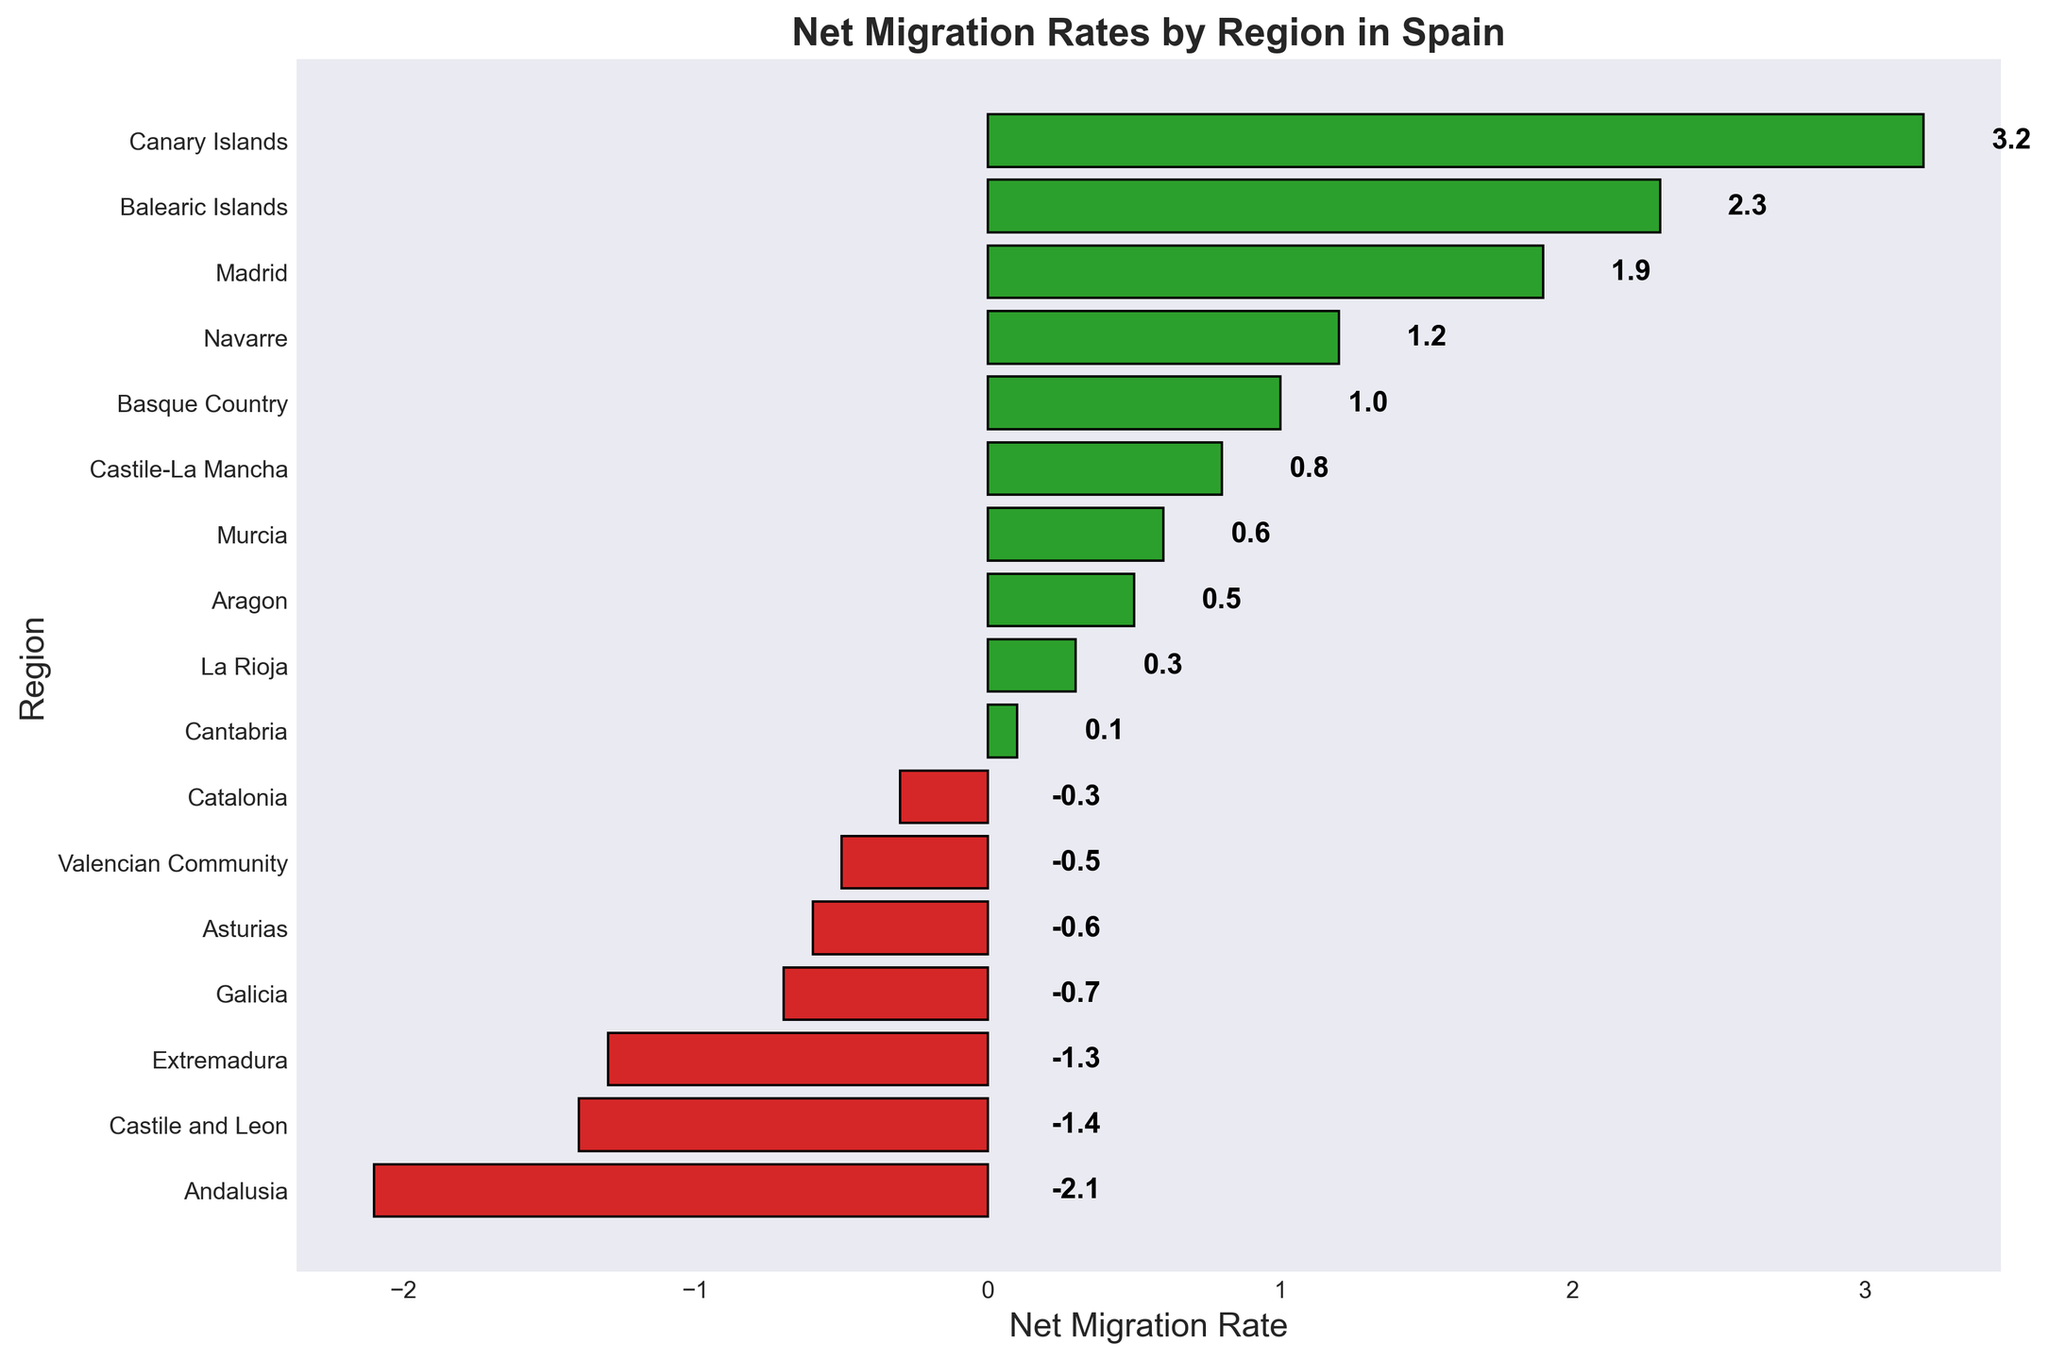What region has the highest net migration rate? The highest net migration rate is represented by the tallest green bar. The tallest green bar belongs to the Canary Islands.
Answer: Canary Islands Which regions have a negative net migration rate? The negative net migration rates are shown by the red bars. These regions include Andalusia, Asturias, Castile and Leon, Extremadura, Galicia, and Valencian Community.
Answer: Andalusia, Asturias, Castile and Leon, Extremadura, Galicia, Valencian Community What is the net migration rate difference between Madrid and Andalusia? The net migration rate for Madrid is 1.9 and for Andalusia is -2.1. The difference is done by subtracting these two values: 1.9 - (-2.1) = 1.9 + 2.1 = 4.0
Answer: 4.0 Which region has a net migration rate of 0.5? The net migration rate of 0.5 is represented by one of the green bars. This bar corresponds to Aragon.
Answer: Aragon Compare the net migration rate between Balearic Islands and Navarre. Which one is higher? The net migration rate for Balearic Islands is 2.3, and for Navarre is 1.2. Since 2.3 is greater than 1.2, the Balearic Islands has a higher net migration rate.
Answer: Balearic Islands What is the average net migration rate of Aragon, Murcia, and La Rioja? The net migration rates are 0.5 for Aragon, 0.6 for Murcia, and 0.3 for La Rioja. The average is calculated as (0.5 + 0.6 + 0.3) / 3 = 1.4 / 3 = 0.467
Answer: 0.467 How many regions have a net migration rate above 1? Green bars above the 1 mark represent the regions with a net migration rate above 1. The regions are Balearic Islands, Canary Islands, Madrid, and Navarre. Therefore, there are 4 regions.
Answer: 4 What is the sum of the net migration rates for Basque Country and Castile-La Mancha? The net migration rate for Basque Country is 1.0 and for Castile-La Mancha is 0.8. The sum is 1.0 + 0.8 = 1.8
Answer: 1.8 Which region has the smallest positive net migration rate? Among the green bars, the smallest positive bar corresponds to Cantabria with a net migration rate of 0.1.
Answer: Cantabria How does the net migration rate of Catalonia compare to that of Asturias? The net migration rate for Catalonia is -0.3 and for Asturias is -0.6. Since -0.3 is greater than -0.6, Catalonia has a less negative net migration rate than Asturias.
Answer: Catalonia 